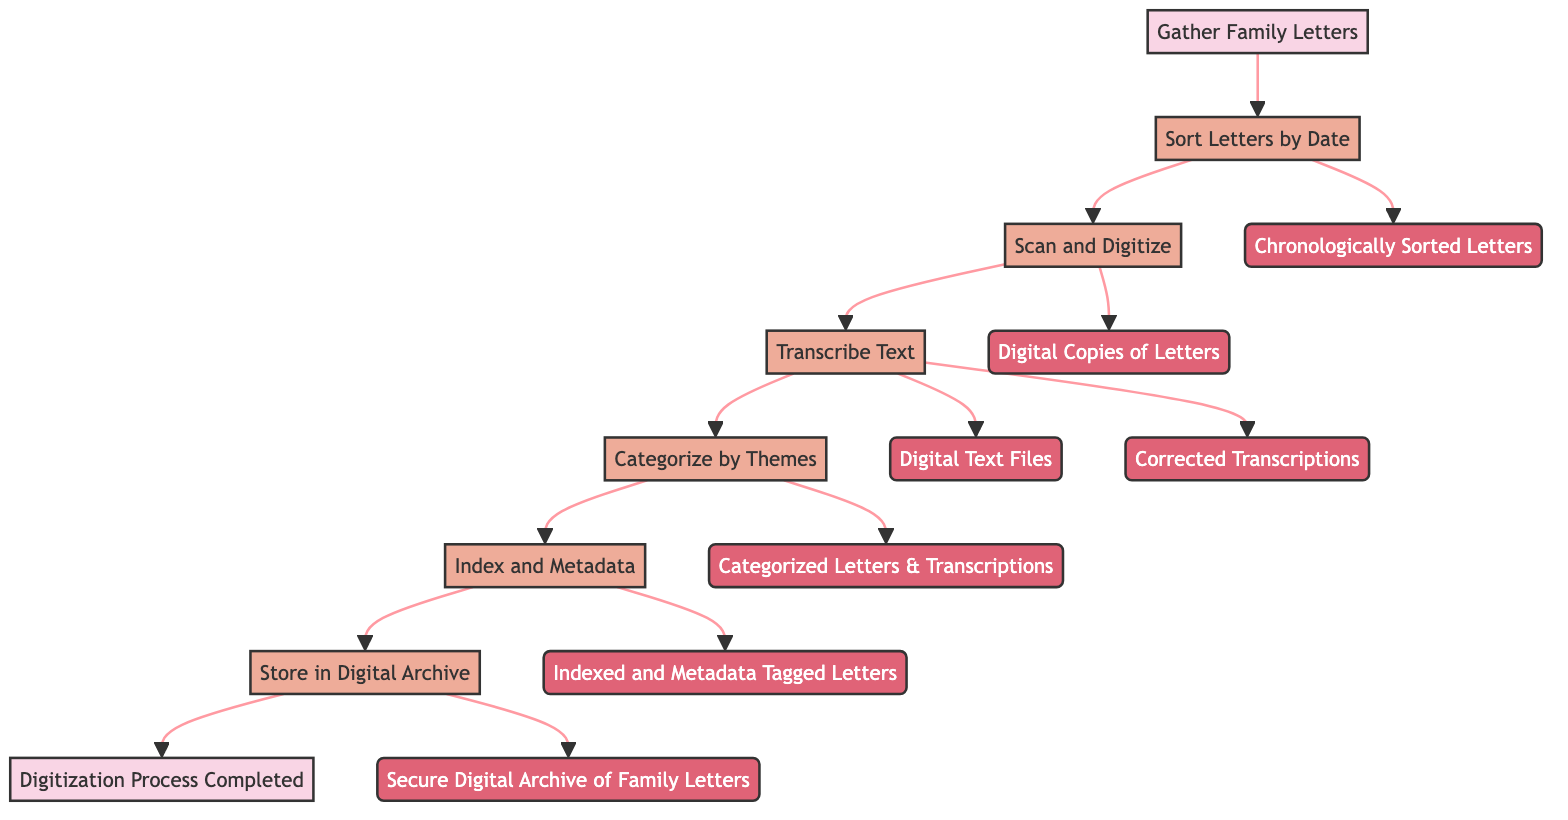What is the first step in the digitization process? The first step shown in the diagram is "Gather Family Letters," which initiates the entire process of digitizing and categorizing family letters.
Answer: Gather Family Letters How many main steps are there in the digitization process? The diagram shows a total of six distinct main steps (from "Sort Letters by Date" to "Store in Digital Archive"), illustrating the entire flow of actions required for the digitization process.
Answer: 6 What follows "Scan and Digitize"? After "Scan and Digitize," the next step in the flow is "Transcribe Text." This shows the progression from scanning the letters to converting the handwritten text into a digital format.
Answer: Transcribe Text What is the output of the "Sort Letters by Date"? The output of the "Sort Letters by Date" step is "Chronologically Sorted Letters," indicating what is produced after completing that step in the digitization process.
Answer: Chronologically Sorted Letters Which step involves adding metadata? The step that involves adding metadata is "Index and Metadata." This is where important details about each letter are compiled during the digitization process.
Answer: Index and Metadata How many outputs result from the "Transcribe Text" step? The "Transcribe Text" step results in two outputs: "Digital Text Files" and "Corrected Transcriptions." This indicates the dual outcomes of the transcription process in the workflow.
Answer: 2 What is the final step of the process? The final step of the digitization process is "Digitization Process Completed," which signifies that all prior steps have been successfully carried out.
Answer: Digitization Process Completed What tools are used in the "Scan and Digitize" step? The tools listed for the "Scan and Digitize" step are "Scanner" and "Document Scanner Software," indicating the equipment necessary for this part of the workflow.
Answer: Scanner, Document Scanner Software What output follows the "Store in Digital Archive"? After the "Store in Digital Archive" step, the outcome is "Secure Digital Archive of Family Letters," which reflects what has been accomplished once the letters are stored.
Answer: Secure Digital Archive of Family Letters 